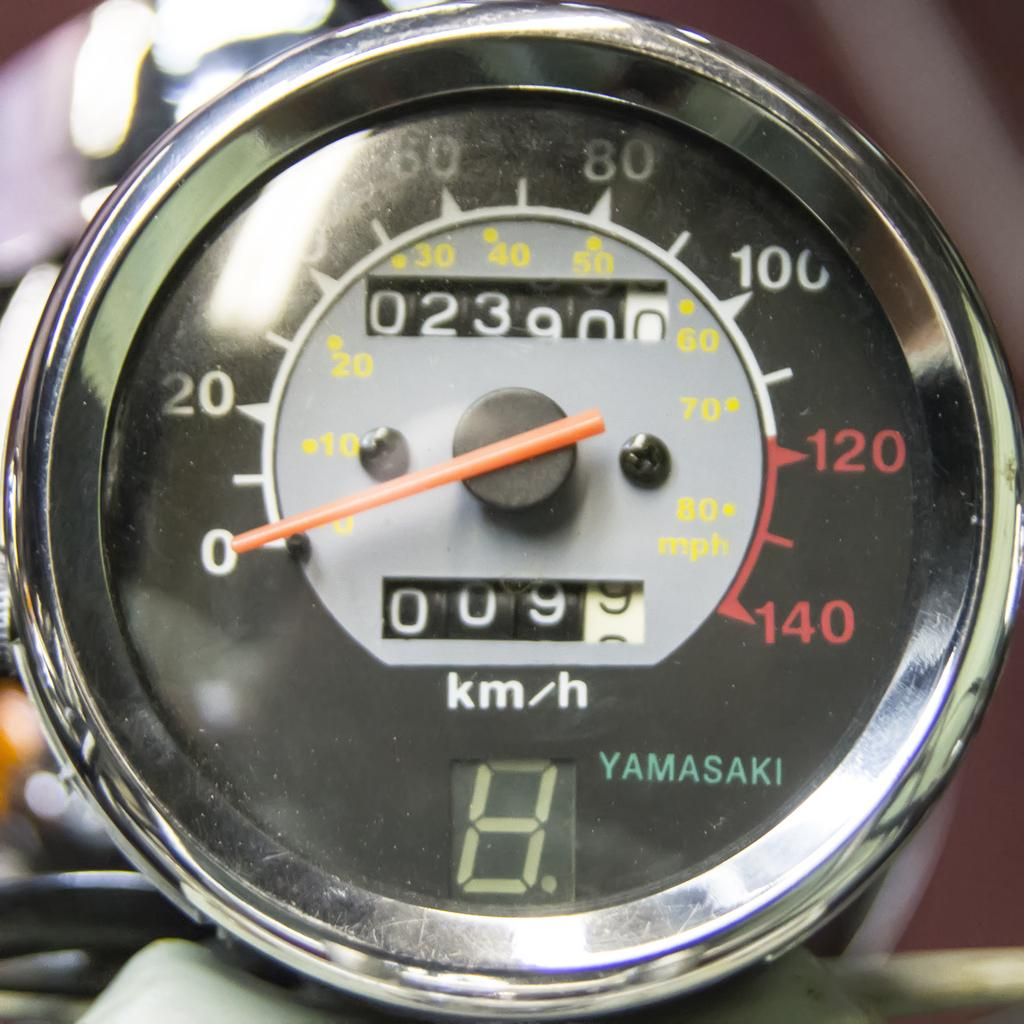<image>
Summarize the visual content of the image. A Yamasaki odometer shows the mileage turning to 23900. 